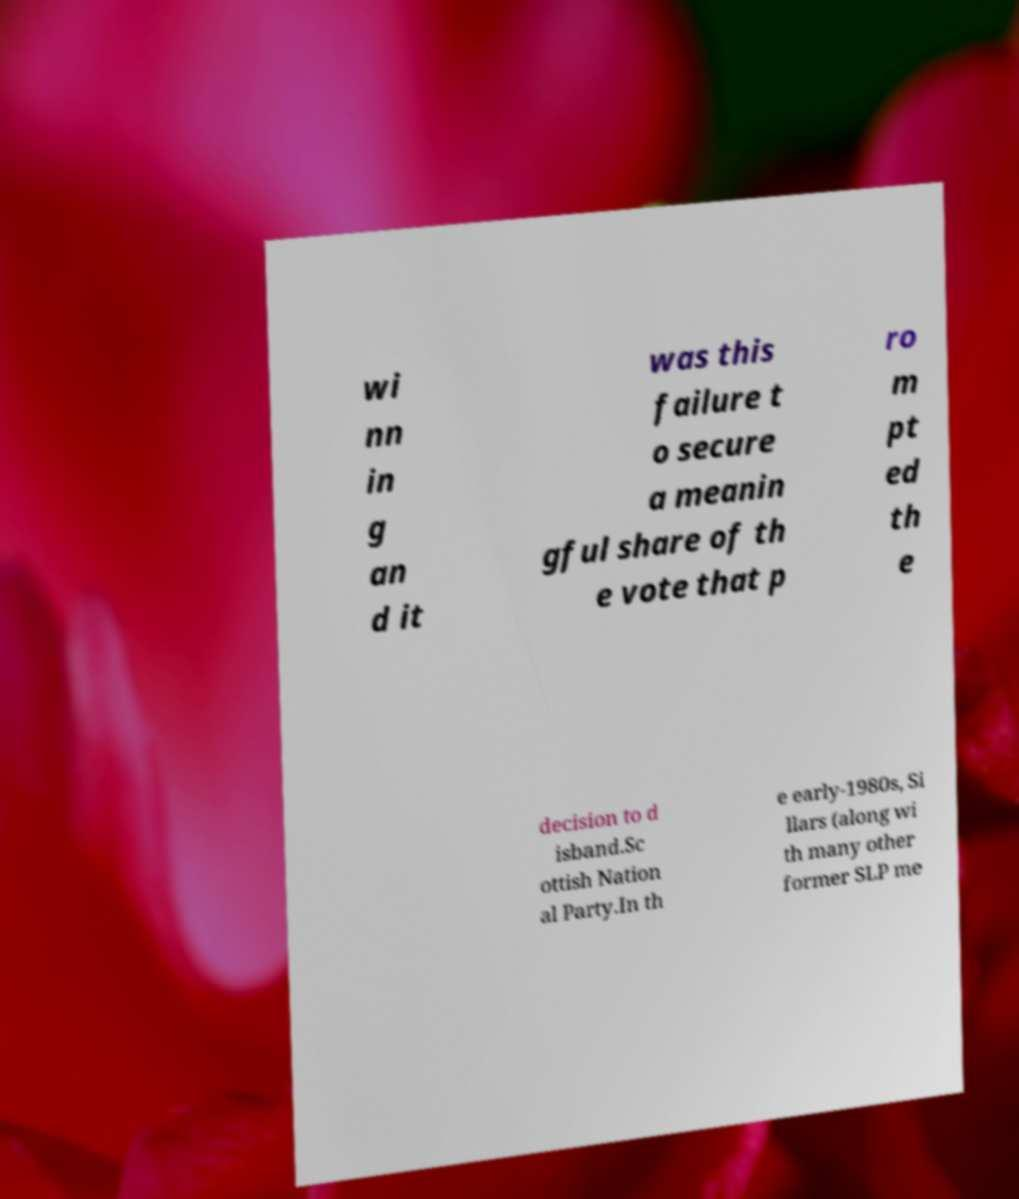Please identify and transcribe the text found in this image. wi nn in g an d it was this failure t o secure a meanin gful share of th e vote that p ro m pt ed th e decision to d isband.Sc ottish Nation al Party.In th e early-1980s, Si llars (along wi th many other former SLP me 